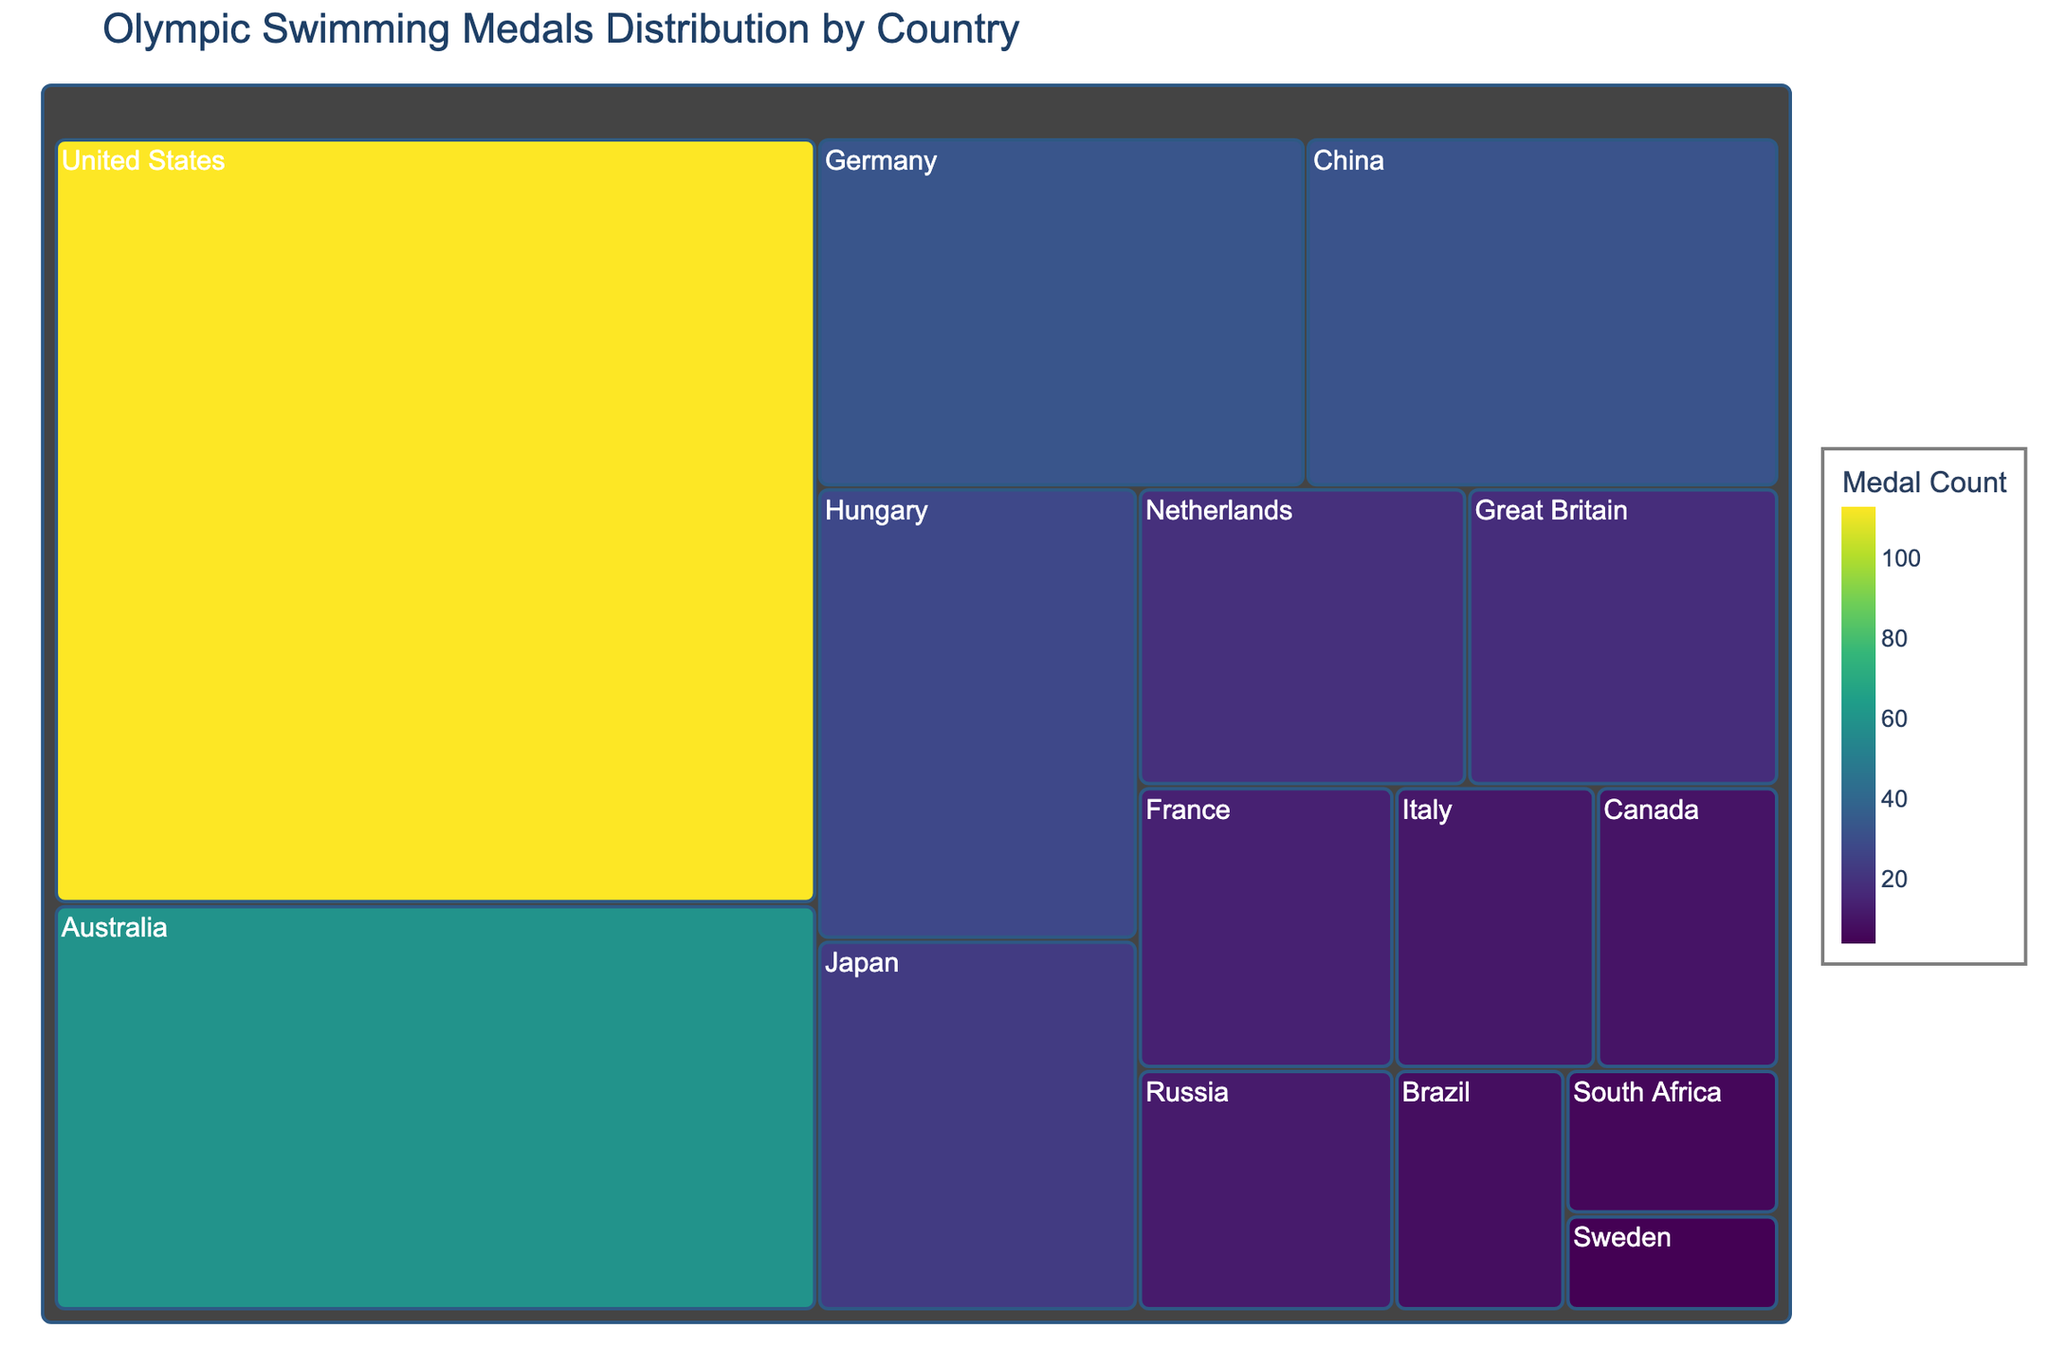What is the title of the treemap? The title is usually located at the top center of the plot, describing what the figure represents.
Answer: Olympic Swimming Medals Distribution by Country How many countries are represented in the treemap? Count the number of distinct countries mentioned in the treemap.
Answer: 15 Which country has won the most gold medals in Olympic swimming? Identify the country with the largest box or highest value in the treemap.
Answer: United States What is the total number of gold medals won by the United States and Australia combined? Locate the boxes for the United States and Australia, then add their medal counts together (113 + 60).
Answer: 173 How many more gold medals has China won compared to Russia? Subtract the number of medals won by Russia from the number won by China (32 - 12).
Answer: 20 Which countries have won exactly 10 gold medals in Olympic swimming? Scan the treemap for countries with a box labeled "10" and list them.
Answer: Canada Arrange Japan, Netherlands, and Great Britain in ascending order of the number of gold medals won. Compare the medal counts of these countries and sort them from the smallest to the largest (Japan: 23, Netherlands: 19, Great Britain: 18).
Answer: Great Britain, Netherlands, Japan Which country has the smallest number of gold medals, and how many? Identify the smallest box in the treemap and read off its value and country.
Answer: Sweden, 4 How many countries have won more than 20 gold medals in Olympic swimming? Count the number of countries with medal counts greater than 20.
Answer: 6 What is the average number of gold medals won by Germany, Hungary, and France? Sum the medal counts of these countries (33 + 28 + 14) and divide by 3 ((33 + 28 + 14)/3).
Answer: 25 